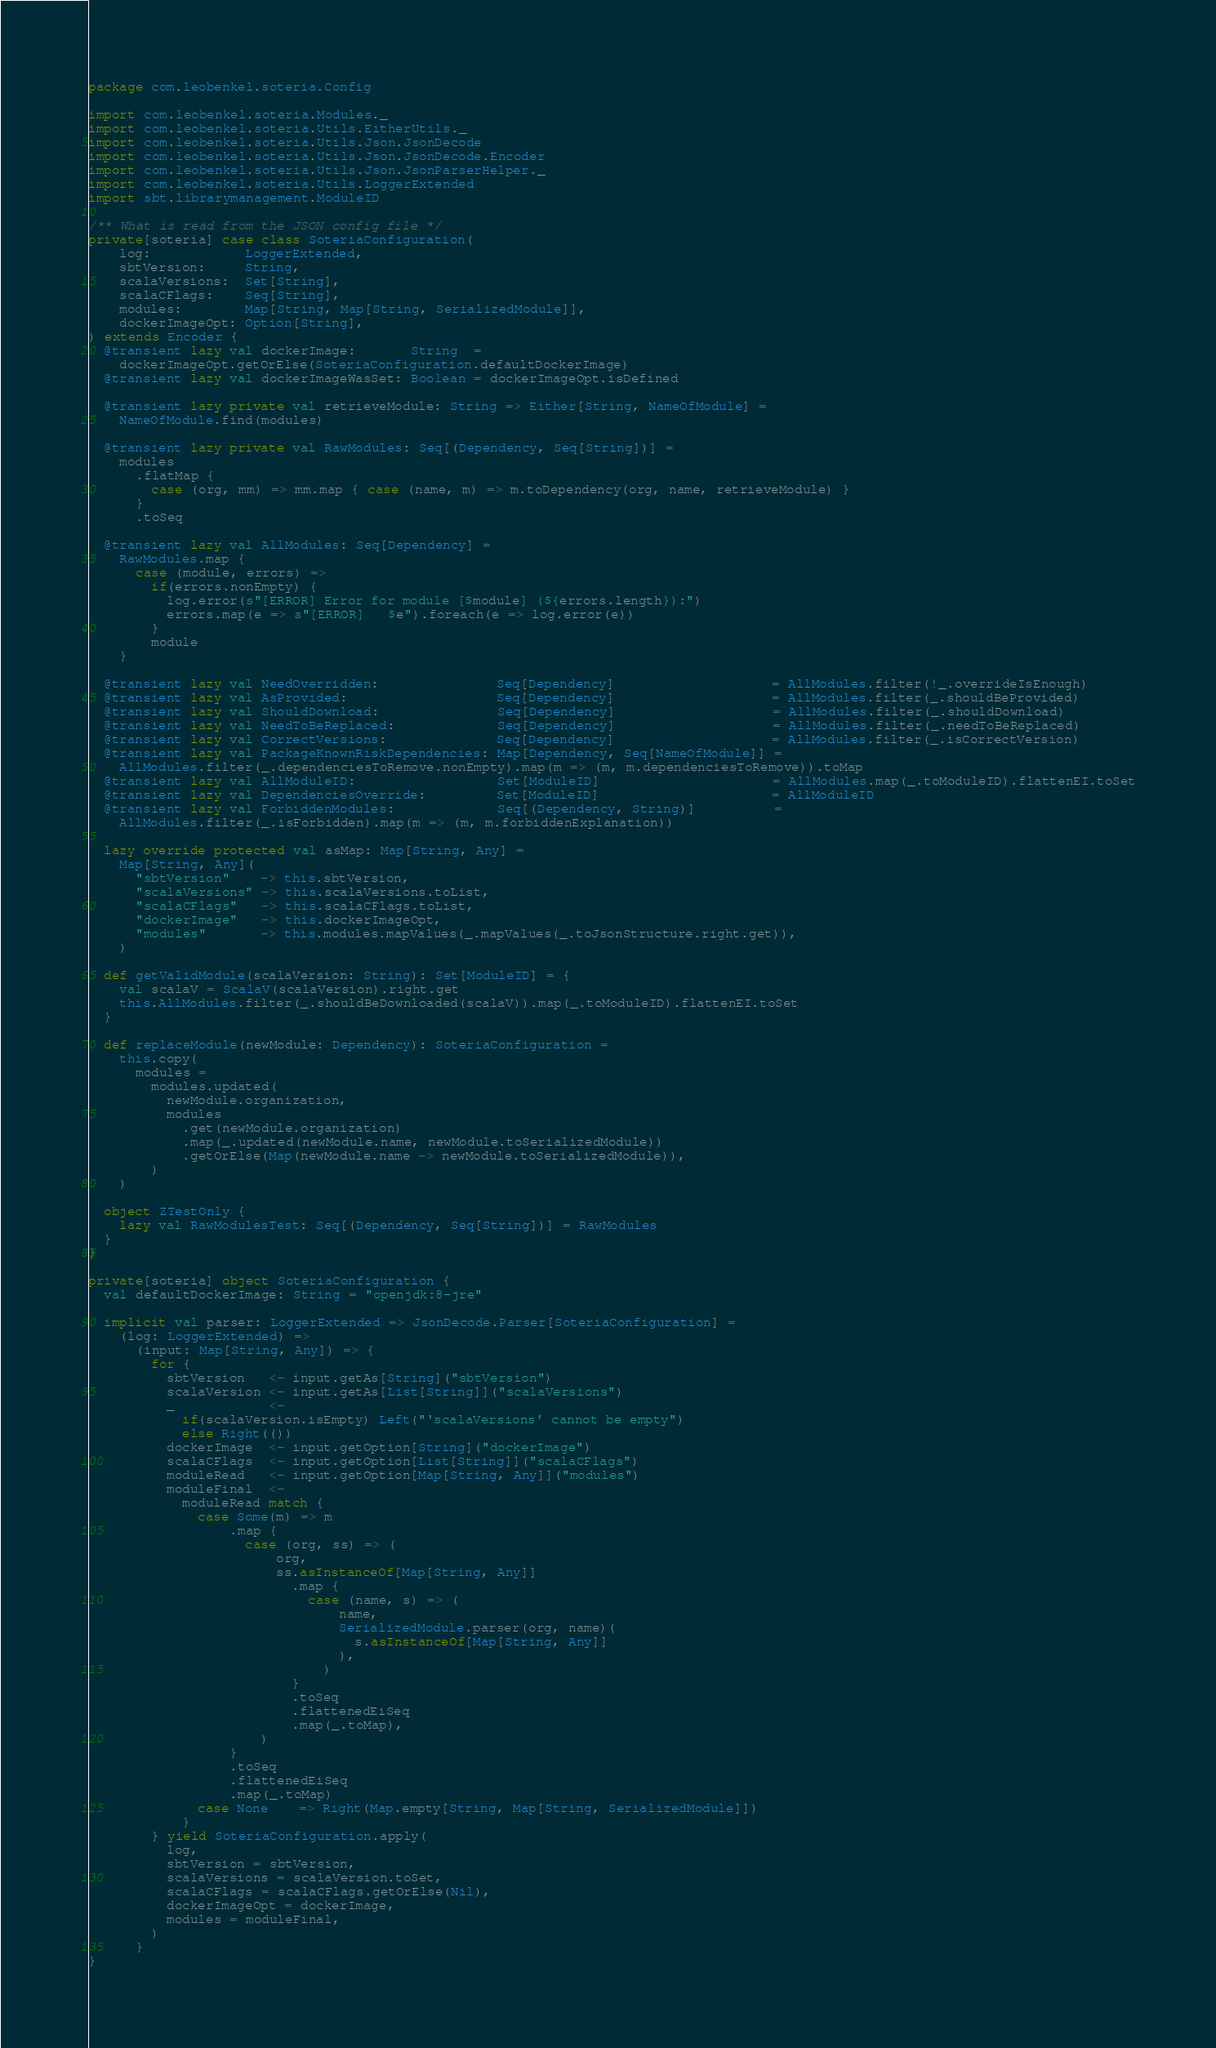Convert code to text. <code><loc_0><loc_0><loc_500><loc_500><_Scala_>package com.leobenkel.soteria.Config

import com.leobenkel.soteria.Modules._
import com.leobenkel.soteria.Utils.EitherUtils._
import com.leobenkel.soteria.Utils.Json.JsonDecode
import com.leobenkel.soteria.Utils.Json.JsonDecode.Encoder
import com.leobenkel.soteria.Utils.Json.JsonParserHelper._
import com.leobenkel.soteria.Utils.LoggerExtended
import sbt.librarymanagement.ModuleID

/** What is read from the JSON config file */
private[soteria] case class SoteriaConfiguration(
    log:            LoggerExtended,
    sbtVersion:     String,
    scalaVersions:  Set[String],
    scalaCFlags:    Seq[String],
    modules:        Map[String, Map[String, SerializedModule]],
    dockerImageOpt: Option[String],
) extends Encoder {
  @transient lazy val dockerImage:       String  =
    dockerImageOpt.getOrElse(SoteriaConfiguration.defaultDockerImage)
  @transient lazy val dockerImageWasSet: Boolean = dockerImageOpt.isDefined

  @transient lazy private val retrieveModule: String => Either[String, NameOfModule] =
    NameOfModule.find(modules)

  @transient lazy private val RawModules: Seq[(Dependency, Seq[String])] =
    modules
      .flatMap {
        case (org, mm) => mm.map { case (name, m) => m.toDependency(org, name, retrieveModule) }
      }
      .toSeq

  @transient lazy val AllModules: Seq[Dependency] =
    RawModules.map {
      case (module, errors) =>
        if(errors.nonEmpty) {
          log.error(s"[ERROR] Error for module [$module] (${errors.length}):")
          errors.map(e => s"[ERROR]   $e").foreach(e => log.error(e))
        }
        module
    }

  @transient lazy val NeedOverridden:               Seq[Dependency]                    = AllModules.filter(!_.overrideIsEnough)
  @transient lazy val AsProvided:                   Seq[Dependency]                    = AllModules.filter(_.shouldBeProvided)
  @transient lazy val ShouldDownload:               Seq[Dependency]                    = AllModules.filter(_.shouldDownload)
  @transient lazy val NeedToBeReplaced:             Seq[Dependency]                    = AllModules.filter(_.needToBeReplaced)
  @transient lazy val CorrectVersions:              Seq[Dependency]                    = AllModules.filter(_.isCorrectVersion)
  @transient lazy val PackageKnownRiskDependencies: Map[Dependency, Seq[NameOfModule]] =
    AllModules.filter(_.dependenciesToRemove.nonEmpty).map(m => (m, m.dependenciesToRemove)).toMap
  @transient lazy val AllModuleID:                  Set[ModuleID]                      = AllModules.map(_.toModuleID).flattenEI.toSet
  @transient lazy val DependenciesOverride:         Set[ModuleID]                      = AllModuleID
  @transient lazy val ForbiddenModules:             Seq[(Dependency, String)]          =
    AllModules.filter(_.isForbidden).map(m => (m, m.forbiddenExplanation))

  lazy override protected val asMap: Map[String, Any] =
    Map[String, Any](
      "sbtVersion"    -> this.sbtVersion,
      "scalaVersions" -> this.scalaVersions.toList,
      "scalaCFlags"   -> this.scalaCFlags.toList,
      "dockerImage"   -> this.dockerImageOpt,
      "modules"       -> this.modules.mapValues(_.mapValues(_.toJsonStructure.right.get)),
    )

  def getValidModule(scalaVersion: String): Set[ModuleID] = {
    val scalaV = ScalaV(scalaVersion).right.get
    this.AllModules.filter(_.shouldBeDownloaded(scalaV)).map(_.toModuleID).flattenEI.toSet
  }

  def replaceModule(newModule: Dependency): SoteriaConfiguration =
    this.copy(
      modules =
        modules.updated(
          newModule.organization,
          modules
            .get(newModule.organization)
            .map(_.updated(newModule.name, newModule.toSerializedModule))
            .getOrElse(Map(newModule.name -> newModule.toSerializedModule)),
        )
    )

  object ZTestOnly {
    lazy val RawModulesTest: Seq[(Dependency, Seq[String])] = RawModules
  }
}

private[soteria] object SoteriaConfiguration {
  val defaultDockerImage: String = "openjdk:8-jre"

  implicit val parser: LoggerExtended => JsonDecode.Parser[SoteriaConfiguration] =
    (log: LoggerExtended) =>
      (input: Map[String, Any]) => {
        for {
          sbtVersion   <- input.getAs[String]("sbtVersion")
          scalaVersion <- input.getAs[List[String]]("scalaVersions")
          _            <-
            if(scalaVersion.isEmpty) Left("'scalaVersions' cannot be empty")
            else Right(())
          dockerImage  <- input.getOption[String]("dockerImage")
          scalaCFlags  <- input.getOption[List[String]]("scalaCFlags")
          moduleRead   <- input.getOption[Map[String, Any]]("modules")
          moduleFinal  <-
            moduleRead match {
              case Some(m) => m
                  .map {
                    case (org, ss) => (
                        org,
                        ss.asInstanceOf[Map[String, Any]]
                          .map {
                            case (name, s) => (
                                name,
                                SerializedModule.parser(org, name)(
                                  s.asInstanceOf[Map[String, Any]]
                                ),
                              )
                          }
                          .toSeq
                          .flattenedEiSeq
                          .map(_.toMap),
                      )
                  }
                  .toSeq
                  .flattenedEiSeq
                  .map(_.toMap)
              case None    => Right(Map.empty[String, Map[String, SerializedModule]])
            }
        } yield SoteriaConfiguration.apply(
          log,
          sbtVersion = sbtVersion,
          scalaVersions = scalaVersion.toSet,
          scalaCFlags = scalaCFlags.getOrElse(Nil),
          dockerImageOpt = dockerImage,
          modules = moduleFinal,
        )
      }
}
</code> 